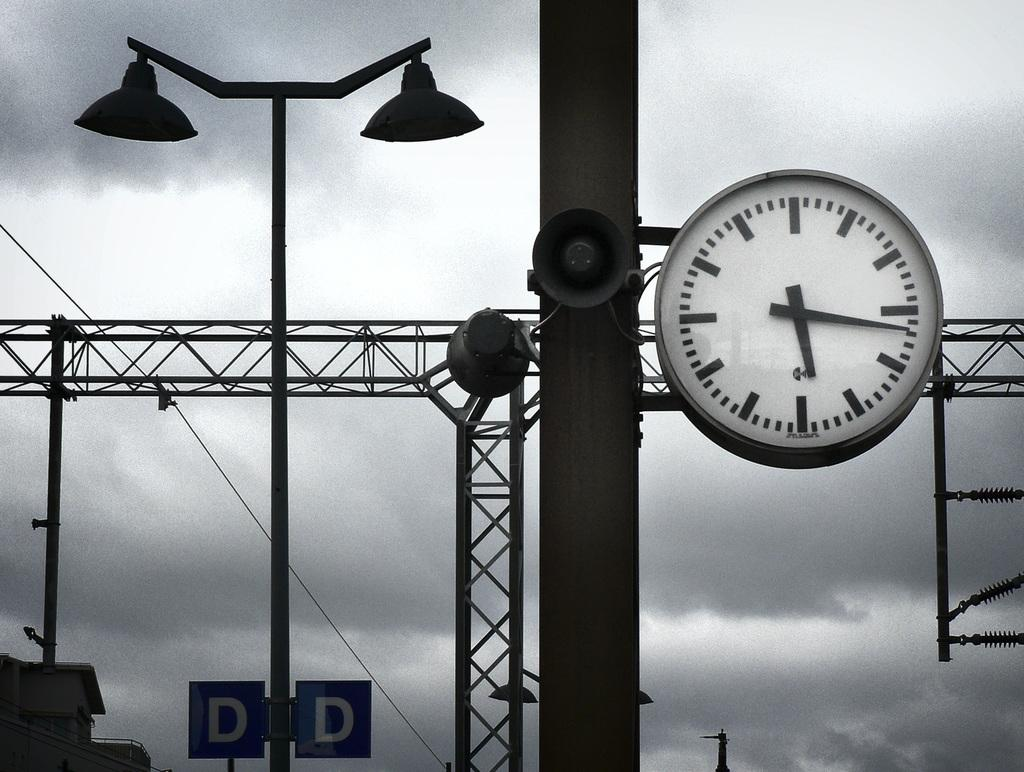<image>
Offer a succinct explanation of the picture presented. the letters D and D that are on a pole 